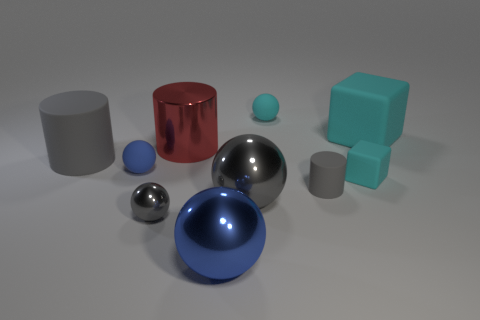What number of tiny cyan balls are right of the gray cylinder that is on the right side of the big blue thing?
Give a very brief answer. 0. What size is the cyan rubber object that is to the right of the tiny gray matte object and behind the tiny cube?
Offer a very short reply. Large. How many shiny objects are either small gray blocks or small things?
Your answer should be very brief. 1. What material is the big blue ball?
Offer a terse response. Metal. There is a cyan thing on the left side of the gray rubber cylinder to the right of the metal thing in front of the small metallic sphere; what is its material?
Provide a succinct answer. Rubber. There is a red thing that is the same size as the blue metal thing; what shape is it?
Your answer should be compact. Cylinder. How many things are tiny yellow blocks or cyan rubber things that are in front of the red shiny cylinder?
Give a very brief answer. 1. Do the gray cylinder to the left of the tiny cyan sphere and the blue thing in front of the tiny gray shiny sphere have the same material?
Your answer should be very brief. No. There is a matte object that is the same color as the tiny cylinder; what shape is it?
Your response must be concise. Cylinder. What number of green objects are large shiny things or tiny shiny things?
Ensure brevity in your answer.  0. 